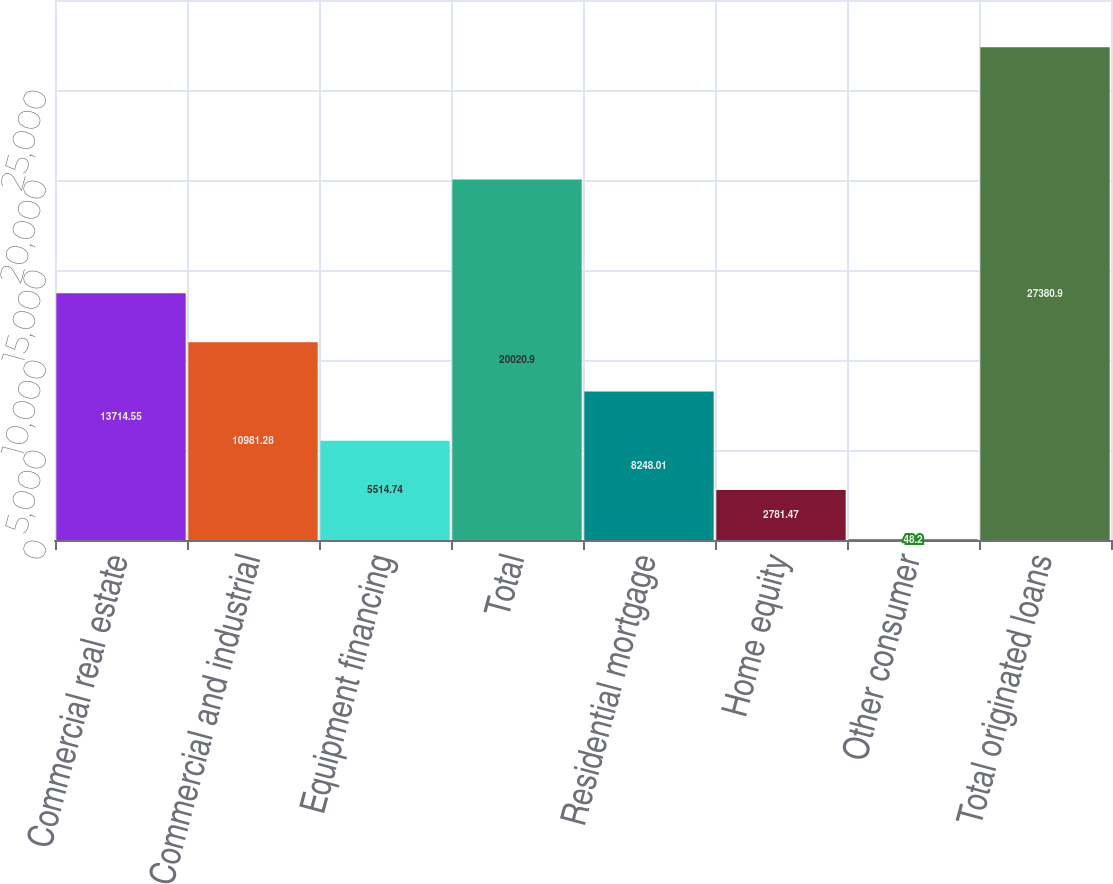<chart> <loc_0><loc_0><loc_500><loc_500><bar_chart><fcel>Commercial real estate<fcel>Commercial and industrial<fcel>Equipment financing<fcel>Total<fcel>Residential mortgage<fcel>Home equity<fcel>Other consumer<fcel>Total originated loans<nl><fcel>13714.5<fcel>10981.3<fcel>5514.74<fcel>20020.9<fcel>8248.01<fcel>2781.47<fcel>48.2<fcel>27380.9<nl></chart> 